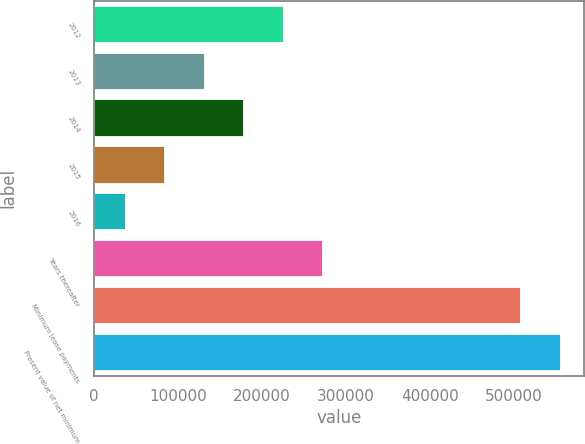Convert chart. <chart><loc_0><loc_0><loc_500><loc_500><bar_chart><fcel>2012<fcel>2013<fcel>2014<fcel>2015<fcel>2016<fcel>Years thereafter<fcel>Minimum lease payments<fcel>Present value of net minimum<nl><fcel>226147<fcel>132055<fcel>179101<fcel>85008.9<fcel>37963<fcel>273192<fcel>508422<fcel>555468<nl></chart> 